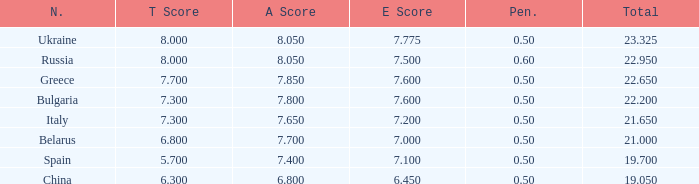What's the sum of A Score that also has a score lower than 7.3 and an E Score larger than 7.1? None. 